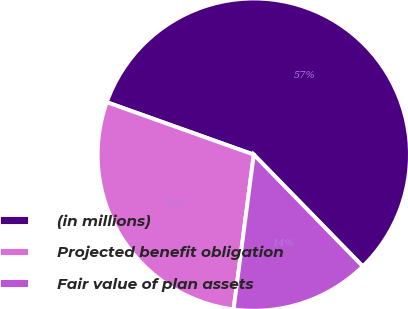Convert chart. <chart><loc_0><loc_0><loc_500><loc_500><pie_chart><fcel>(in millions)<fcel>Projected benefit obligation<fcel>Fair value of plan assets<nl><fcel>57.24%<fcel>28.38%<fcel>14.37%<nl></chart> 